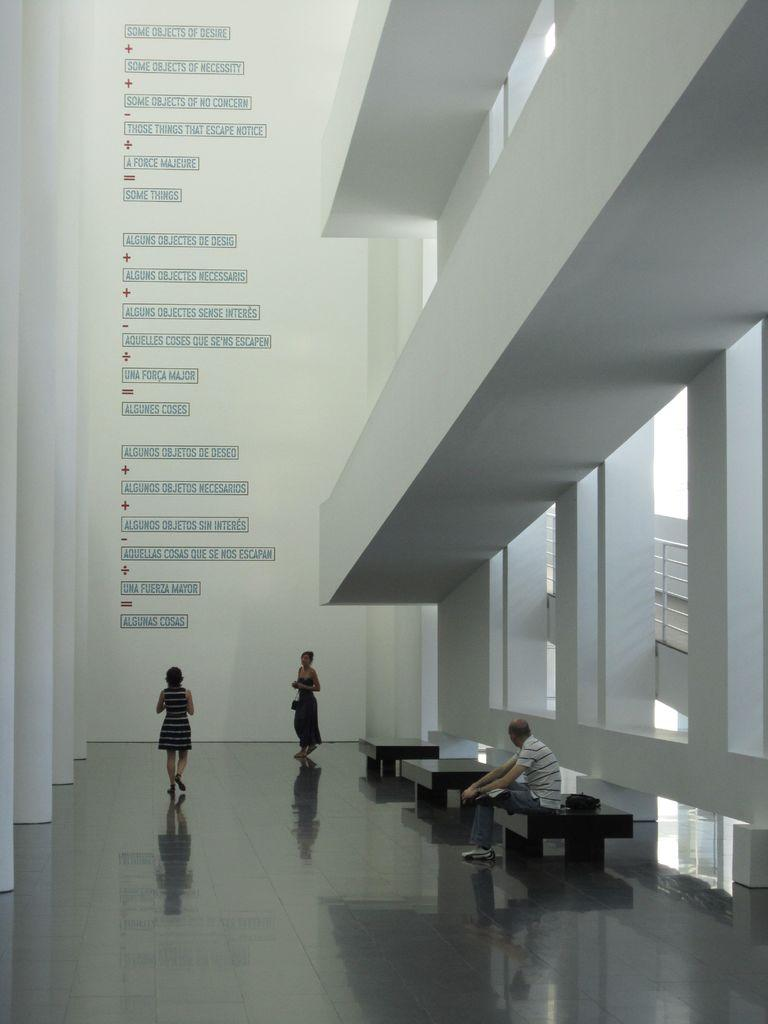How many people are in the image? There are three people in the image. What are the women doing in the image? The women are standing in the image. What is the man doing in the image? The man is sitting in the image. What song is the crook singing in the image? There is no crook or singing present in the image. What type of maid is visible in the image? There is no maid present in the image. 